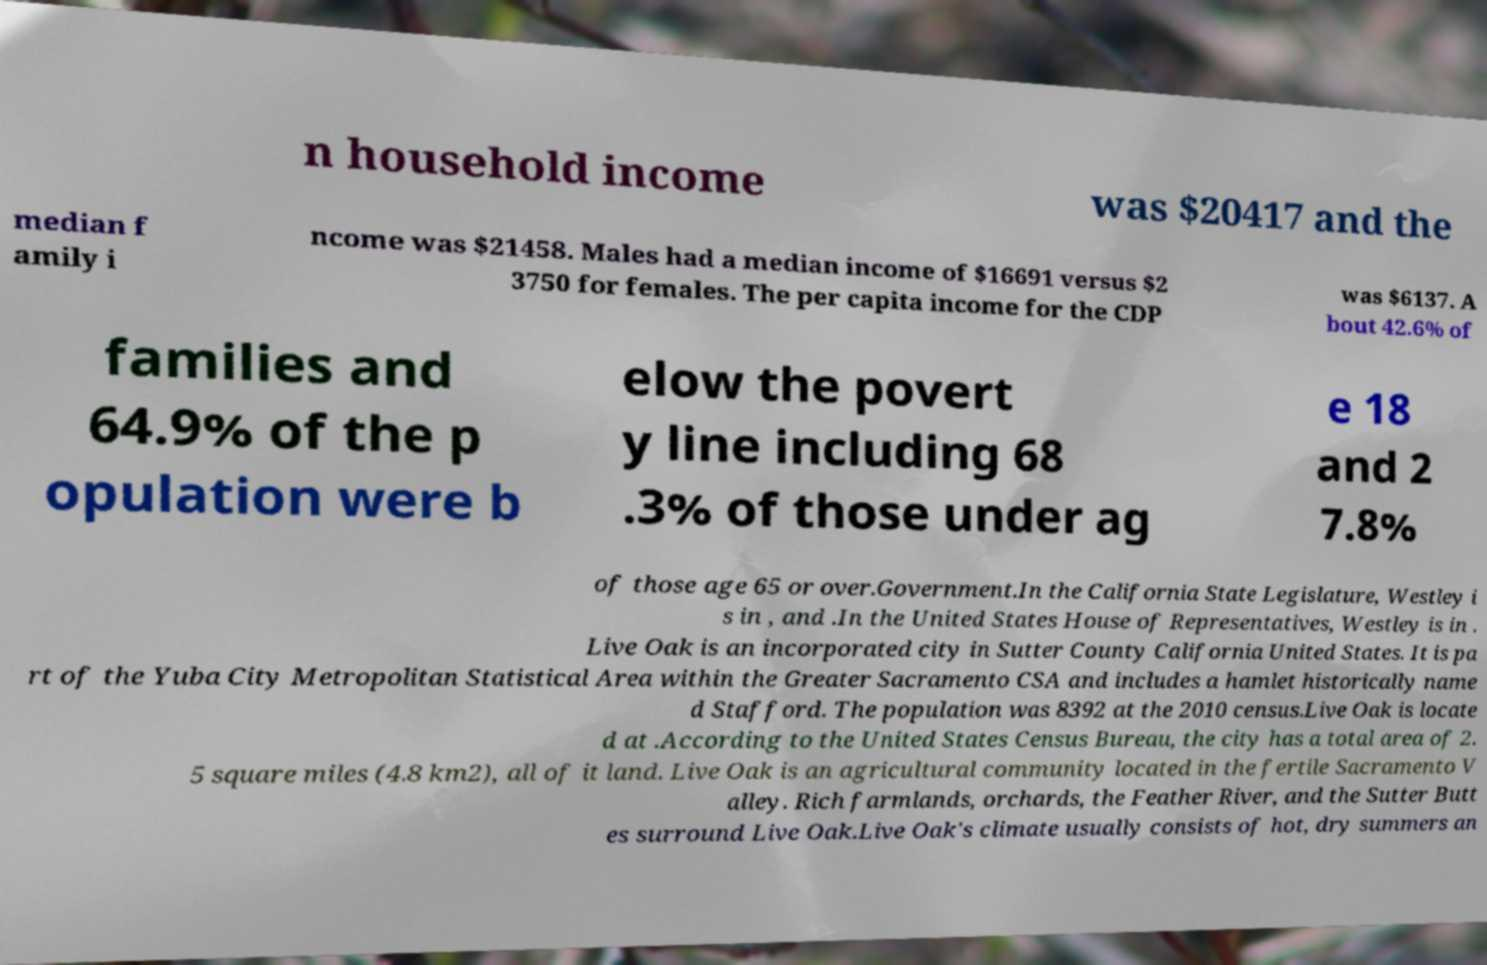Please identify and transcribe the text found in this image. n household income was $20417 and the median f amily i ncome was $21458. Males had a median income of $16691 versus $2 3750 for females. The per capita income for the CDP was $6137. A bout 42.6% of families and 64.9% of the p opulation were b elow the povert y line including 68 .3% of those under ag e 18 and 2 7.8% of those age 65 or over.Government.In the California State Legislature, Westley i s in , and .In the United States House of Representatives, Westley is in . Live Oak is an incorporated city in Sutter County California United States. It is pa rt of the Yuba City Metropolitan Statistical Area within the Greater Sacramento CSA and includes a hamlet historically name d Stafford. The population was 8392 at the 2010 census.Live Oak is locate d at .According to the United States Census Bureau, the city has a total area of 2. 5 square miles (4.8 km2), all of it land. Live Oak is an agricultural community located in the fertile Sacramento V alley. Rich farmlands, orchards, the Feather River, and the Sutter Butt es surround Live Oak.Live Oak's climate usually consists of hot, dry summers an 